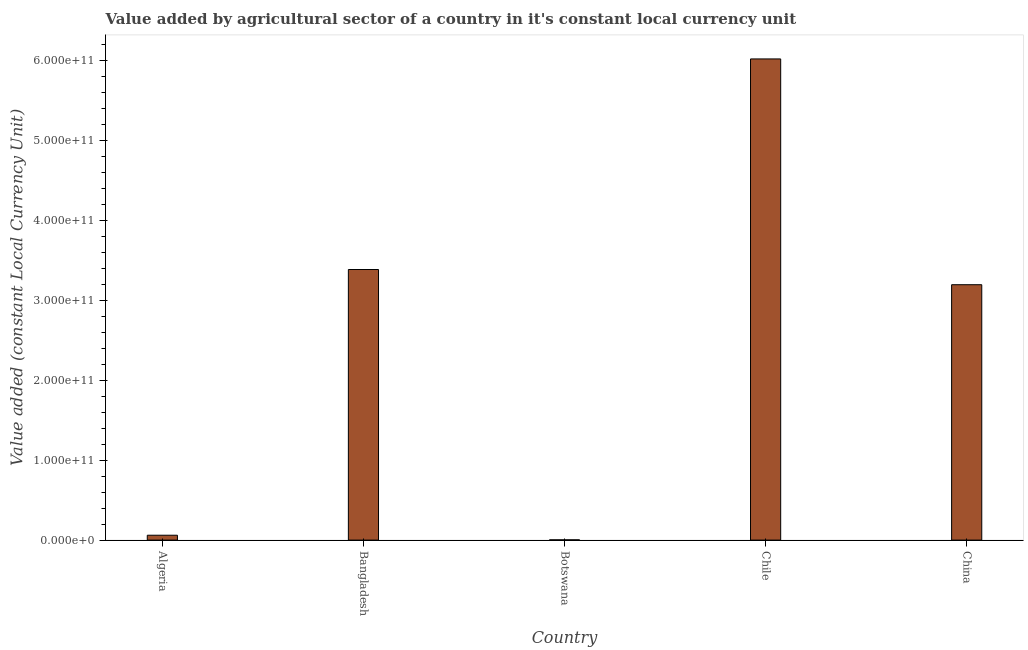Does the graph contain any zero values?
Provide a succinct answer. No. What is the title of the graph?
Your answer should be compact. Value added by agricultural sector of a country in it's constant local currency unit. What is the label or title of the X-axis?
Your response must be concise. Country. What is the label or title of the Y-axis?
Your response must be concise. Value added (constant Local Currency Unit). What is the value added by agriculture sector in Bangladesh?
Ensure brevity in your answer.  3.38e+11. Across all countries, what is the maximum value added by agriculture sector?
Keep it short and to the point. 6.02e+11. Across all countries, what is the minimum value added by agriculture sector?
Ensure brevity in your answer.  3.07e+08. In which country was the value added by agriculture sector minimum?
Keep it short and to the point. Botswana. What is the sum of the value added by agriculture sector?
Provide a succinct answer. 1.27e+12. What is the difference between the value added by agriculture sector in Chile and China?
Provide a succinct answer. 2.82e+11. What is the average value added by agriculture sector per country?
Give a very brief answer. 2.53e+11. What is the median value added by agriculture sector?
Offer a very short reply. 3.19e+11. What is the ratio of the value added by agriculture sector in Bangladesh to that in Chile?
Offer a terse response. 0.56. What is the difference between the highest and the second highest value added by agriculture sector?
Your response must be concise. 2.63e+11. Is the sum of the value added by agriculture sector in Chile and China greater than the maximum value added by agriculture sector across all countries?
Your answer should be very brief. Yes. What is the difference between the highest and the lowest value added by agriculture sector?
Your answer should be very brief. 6.01e+11. Are all the bars in the graph horizontal?
Provide a short and direct response. No. What is the difference between two consecutive major ticks on the Y-axis?
Ensure brevity in your answer.  1.00e+11. What is the Value added (constant Local Currency Unit) in Algeria?
Provide a succinct answer. 6.09e+09. What is the Value added (constant Local Currency Unit) in Bangladesh?
Give a very brief answer. 3.38e+11. What is the Value added (constant Local Currency Unit) of Botswana?
Keep it short and to the point. 3.07e+08. What is the Value added (constant Local Currency Unit) of Chile?
Your answer should be compact. 6.02e+11. What is the Value added (constant Local Currency Unit) of China?
Your answer should be compact. 3.19e+11. What is the difference between the Value added (constant Local Currency Unit) in Algeria and Bangladesh?
Offer a very short reply. -3.32e+11. What is the difference between the Value added (constant Local Currency Unit) in Algeria and Botswana?
Provide a short and direct response. 5.78e+09. What is the difference between the Value added (constant Local Currency Unit) in Algeria and Chile?
Keep it short and to the point. -5.96e+11. What is the difference between the Value added (constant Local Currency Unit) in Algeria and China?
Provide a short and direct response. -3.13e+11. What is the difference between the Value added (constant Local Currency Unit) in Bangladesh and Botswana?
Offer a very short reply. 3.38e+11. What is the difference between the Value added (constant Local Currency Unit) in Bangladesh and Chile?
Ensure brevity in your answer.  -2.63e+11. What is the difference between the Value added (constant Local Currency Unit) in Bangladesh and China?
Your answer should be very brief. 1.90e+1. What is the difference between the Value added (constant Local Currency Unit) in Botswana and Chile?
Give a very brief answer. -6.01e+11. What is the difference between the Value added (constant Local Currency Unit) in Botswana and China?
Provide a short and direct response. -3.19e+11. What is the difference between the Value added (constant Local Currency Unit) in Chile and China?
Make the answer very short. 2.82e+11. What is the ratio of the Value added (constant Local Currency Unit) in Algeria to that in Bangladesh?
Keep it short and to the point. 0.02. What is the ratio of the Value added (constant Local Currency Unit) in Algeria to that in Botswana?
Make the answer very short. 19.84. What is the ratio of the Value added (constant Local Currency Unit) in Algeria to that in China?
Offer a very short reply. 0.02. What is the ratio of the Value added (constant Local Currency Unit) in Bangladesh to that in Botswana?
Offer a very short reply. 1103.4. What is the ratio of the Value added (constant Local Currency Unit) in Bangladesh to that in Chile?
Keep it short and to the point. 0.56. What is the ratio of the Value added (constant Local Currency Unit) in Bangladesh to that in China?
Ensure brevity in your answer.  1.06. What is the ratio of the Value added (constant Local Currency Unit) in Botswana to that in Chile?
Provide a short and direct response. 0. What is the ratio of the Value added (constant Local Currency Unit) in Chile to that in China?
Your answer should be compact. 1.88. 